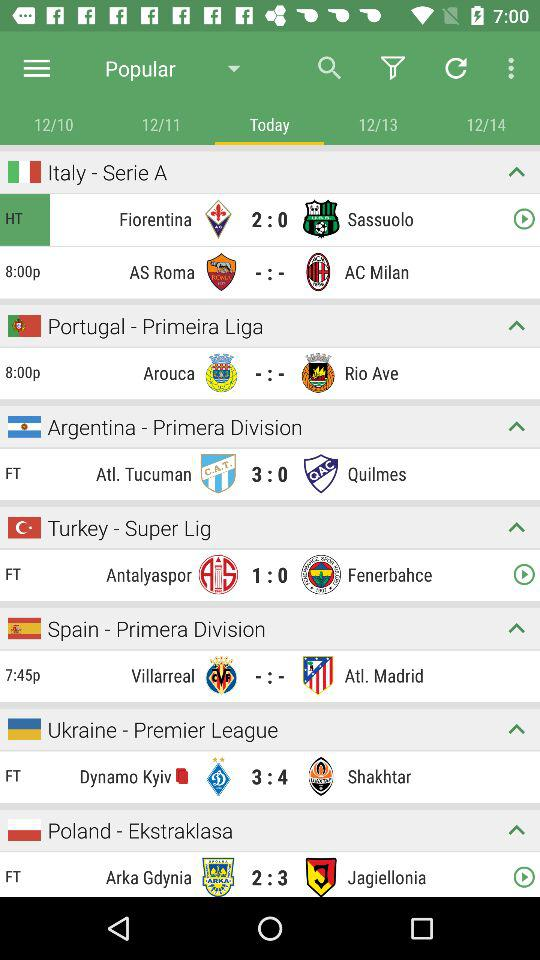What is the time of the match in "Spain - Primera Division"? The time of the match is 7:45 p.m. 